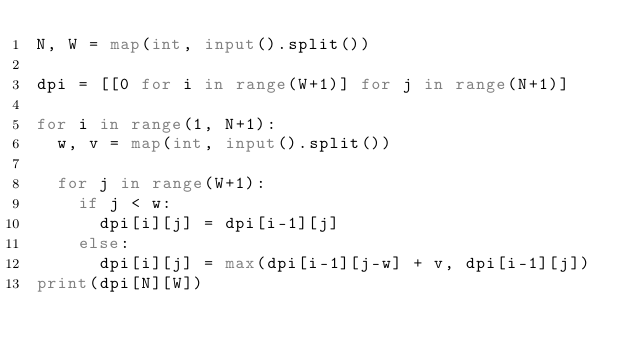<code> <loc_0><loc_0><loc_500><loc_500><_Python_>N, W = map(int, input().split())

dpi = [[0 for i in range(W+1)] for j in range(N+1)]

for i in range(1, N+1):
  w, v = map(int, input().split())
  
  for j in range(W+1):
    if j < w:
      dpi[i][j] = dpi[i-1][j]
    else:
      dpi[i][j] = max(dpi[i-1][j-w] + v, dpi[i-1][j])
print(dpi[N][W])</code> 